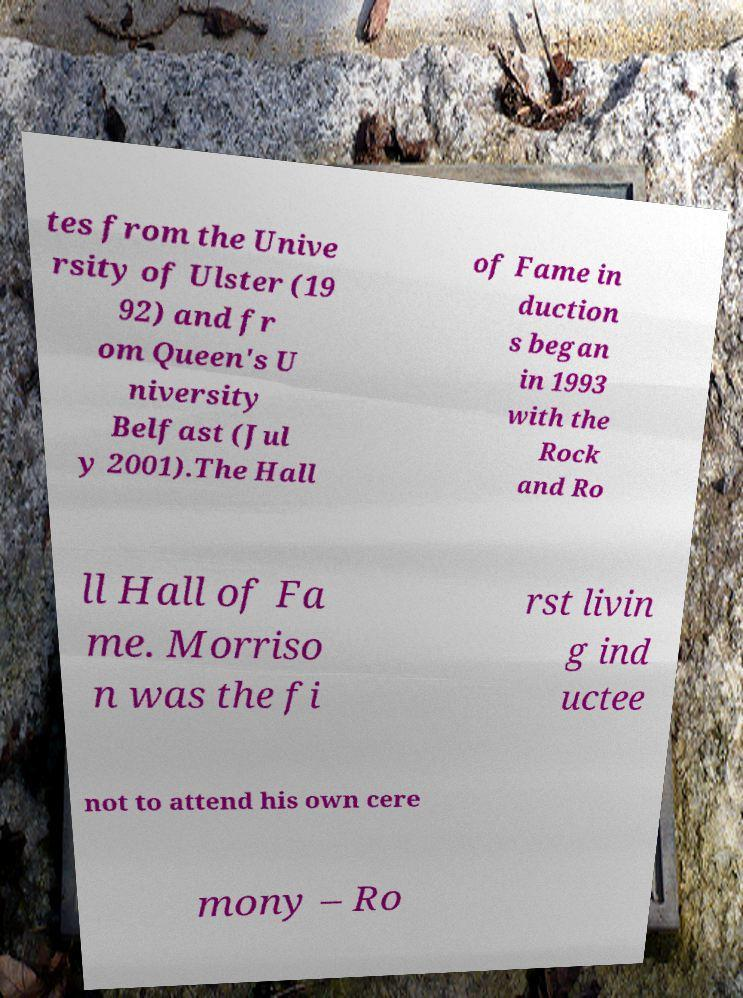I need the written content from this picture converted into text. Can you do that? tes from the Unive rsity of Ulster (19 92) and fr om Queen's U niversity Belfast (Jul y 2001).The Hall of Fame in duction s began in 1993 with the Rock and Ro ll Hall of Fa me. Morriso n was the fi rst livin g ind uctee not to attend his own cere mony – Ro 